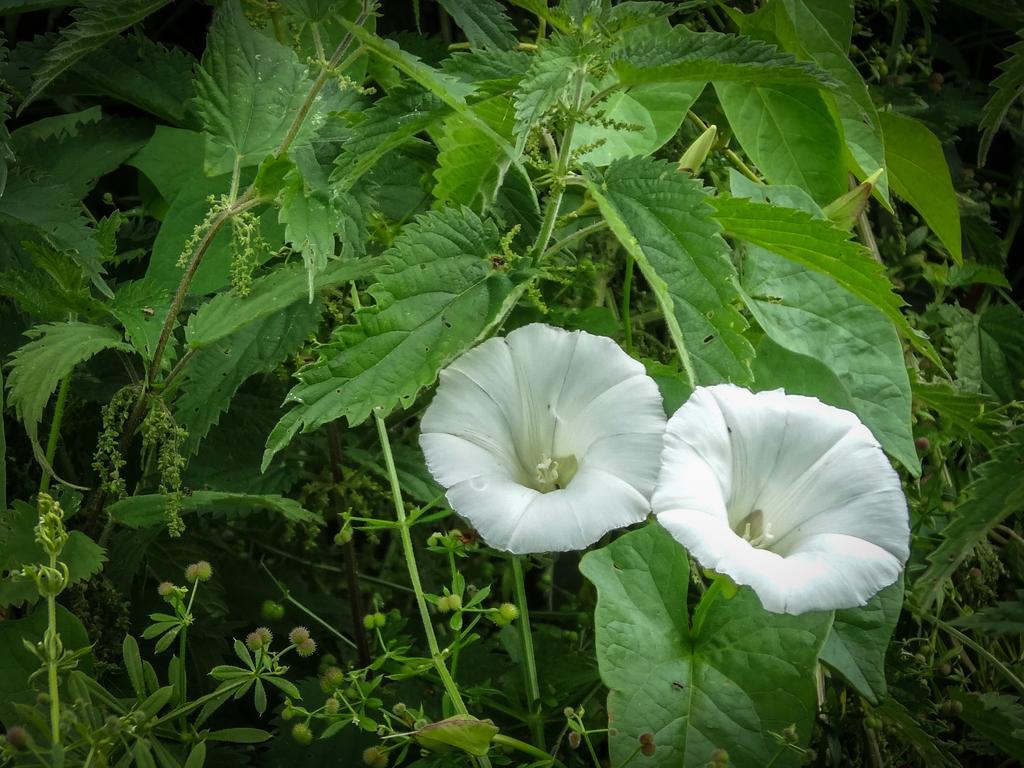In one or two sentences, can you explain what this image depicts? In this image we can see two white color flower, leaves and stems. 